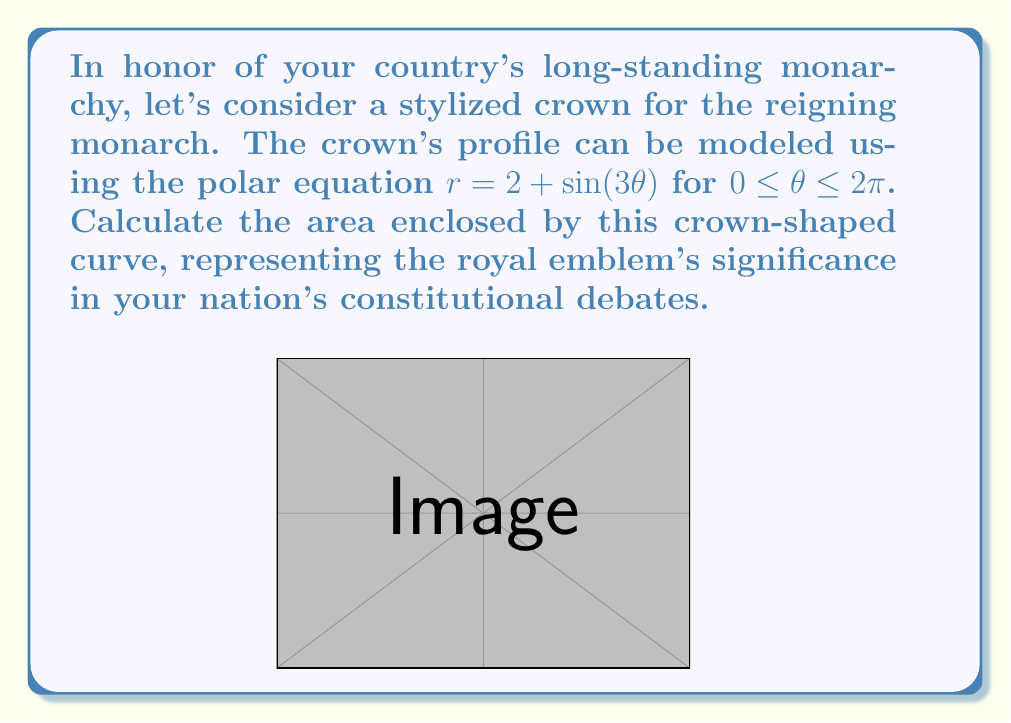Provide a solution to this math problem. To calculate the area enclosed by the polar curve $r = 2 + \sin(3\theta)$, we'll use the formula for the area of a polar region:

$$A = \frac{1}{2} \int_{0}^{2\pi} r^2 d\theta$$

Let's break this down step-by-step:

1) First, we need to square our $r$ function:
   $r^2 = (2 + \sin(3\theta))^2 = 4 + 4\sin(3\theta) + \sin^2(3\theta)$

2) Now, we can set up our integral:
   $$A = \frac{1}{2} \int_{0}^{2\pi} (4 + 4\sin(3\theta) + \sin^2(3\theta)) d\theta$$

3) Let's integrate each term separately:
   
   a) $\int_{0}^{2\pi} 4 d\theta = 4\theta \big|_{0}^{2\pi} = 8\pi$
   
   b) $\int_{0}^{2\pi} 4\sin(3\theta) d\theta = -\frac{4}{3}\cos(3\theta) \big|_{0}^{2\pi} = 0$
   
   c) For $\int_{0}^{2\pi} \sin^2(3\theta) d\theta$, we can use the identity $\sin^2 x = \frac{1}{2}(1 - \cos(2x))$:
      
      $\int_{0}^{2\pi} \sin^2(3\theta) d\theta = \int_{0}^{2\pi} \frac{1}{2}(1 - \cos(6\theta)) d\theta$
      
      $= \frac{1}{2}\theta - \frac{1}{12}\sin(6\theta) \big|_{0}^{2\pi} = \pi$

4) Adding these results:
   $$A = \frac{1}{2}(8\pi + 0 + \pi) = \frac{9\pi}{2}$$

Thus, the area enclosed by the crown-shaped curve is $\frac{9\pi}{2}$ square units.
Answer: $\frac{9\pi}{2}$ square units 